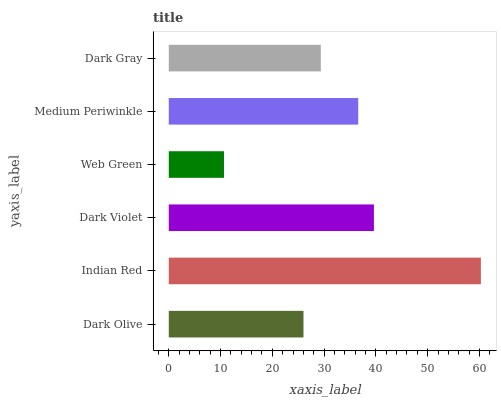Is Web Green the minimum?
Answer yes or no. Yes. Is Indian Red the maximum?
Answer yes or no. Yes. Is Dark Violet the minimum?
Answer yes or no. No. Is Dark Violet the maximum?
Answer yes or no. No. Is Indian Red greater than Dark Violet?
Answer yes or no. Yes. Is Dark Violet less than Indian Red?
Answer yes or no. Yes. Is Dark Violet greater than Indian Red?
Answer yes or no. No. Is Indian Red less than Dark Violet?
Answer yes or no. No. Is Medium Periwinkle the high median?
Answer yes or no. Yes. Is Dark Gray the low median?
Answer yes or no. Yes. Is Dark Gray the high median?
Answer yes or no. No. Is Web Green the low median?
Answer yes or no. No. 